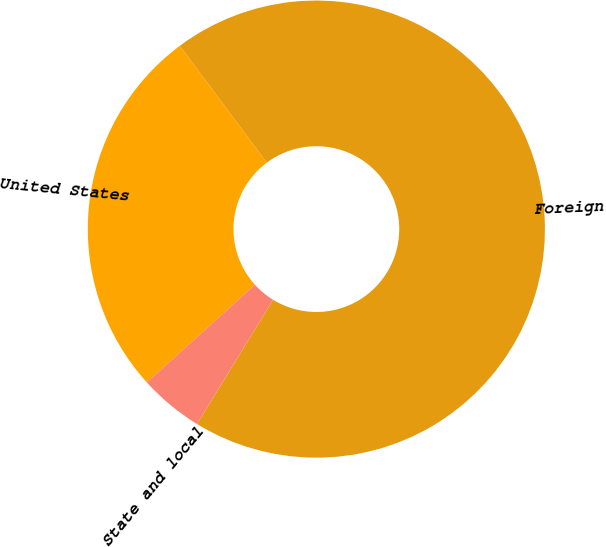Convert chart to OTSL. <chart><loc_0><loc_0><loc_500><loc_500><pie_chart><fcel>United States<fcel>Foreign<fcel>State and local<nl><fcel>26.52%<fcel>68.94%<fcel>4.55%<nl></chart> 